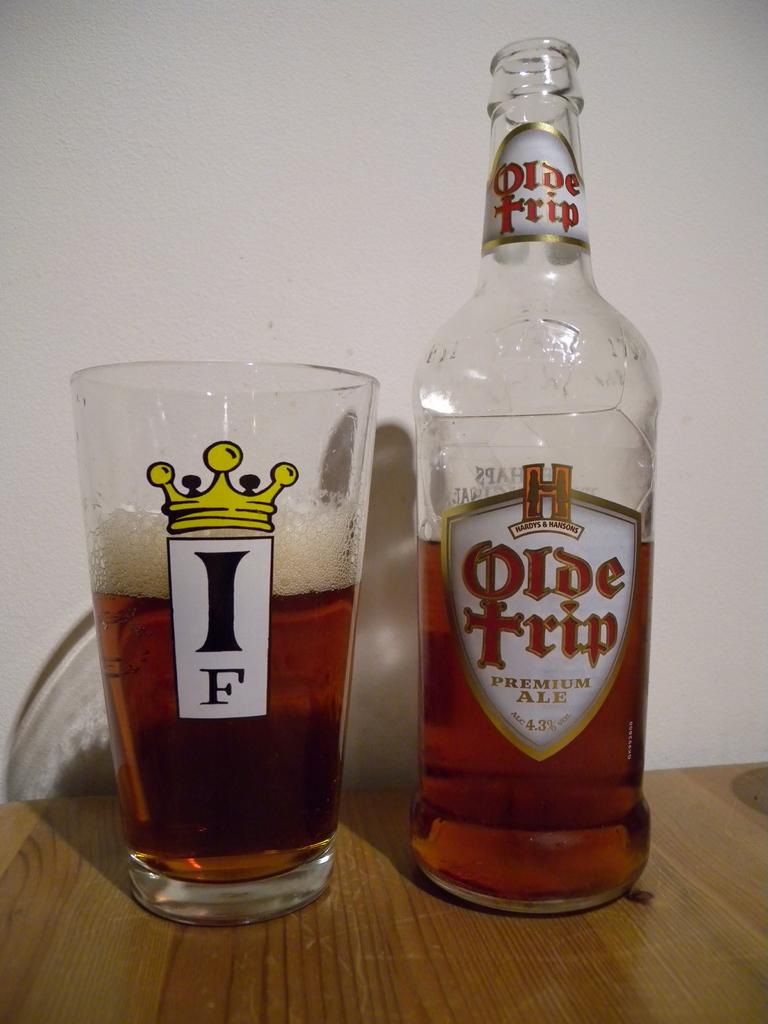<image>
Provide a brief description of the given image. Olde Trip bottle of premium ale with a glass cup on the left. 